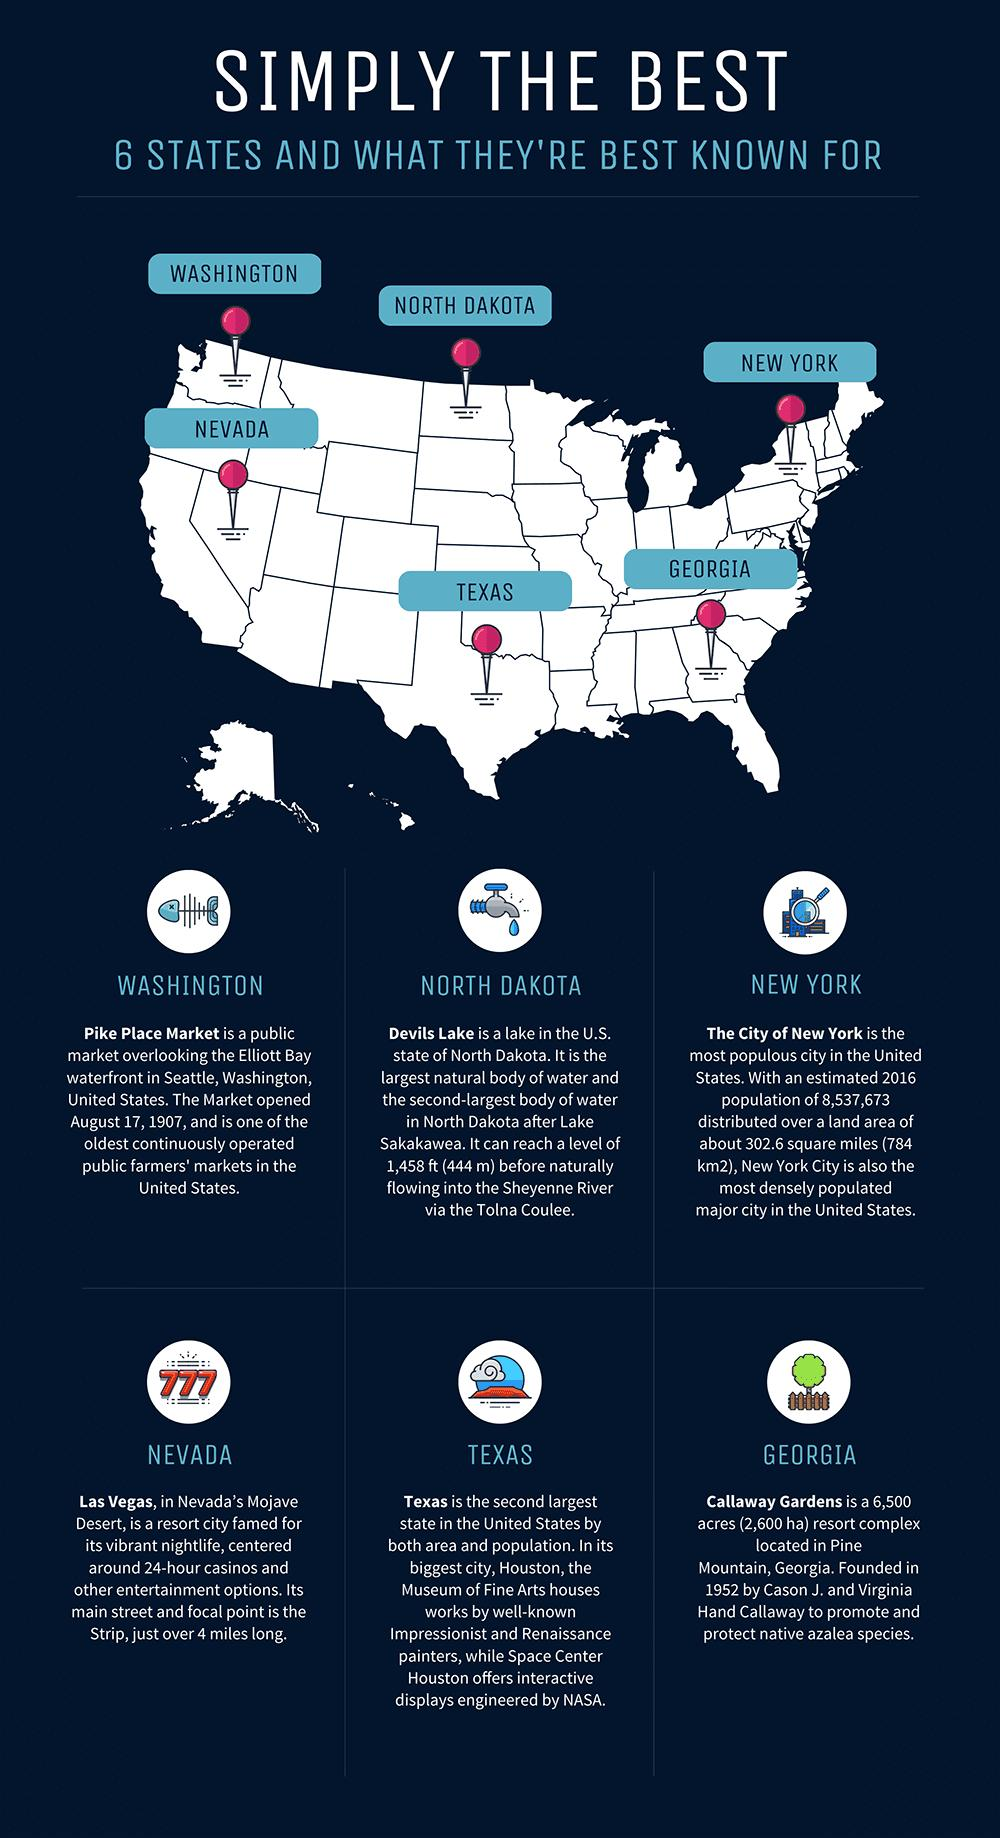Highlight a few significant elements in this photo. Texas is the second largest state in the United States. Devils Lake is the second largest natural body of water in the U.S. state of North Dakota. The Pike Place Market was opened in the United States on August 17, 1907. The estimated population of New York in the year 2016 was approximately 8,537,673. The most densely populated city in the United States is the City of New York. 